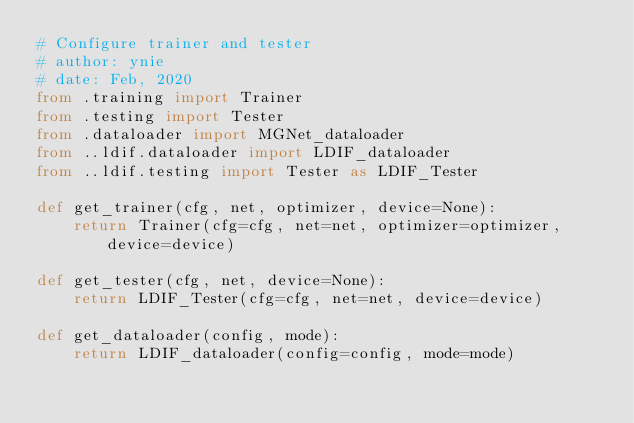Convert code to text. <code><loc_0><loc_0><loc_500><loc_500><_Python_># Configure trainer and tester
# author: ynie
# date: Feb, 2020
from .training import Trainer
from .testing import Tester
from .dataloader import MGNet_dataloader
from ..ldif.dataloader import LDIF_dataloader
from ..ldif.testing import Tester as LDIF_Tester

def get_trainer(cfg, net, optimizer, device=None):
    return Trainer(cfg=cfg, net=net, optimizer=optimizer, device=device)

def get_tester(cfg, net, device=None):
    return LDIF_Tester(cfg=cfg, net=net, device=device)

def get_dataloader(config, mode):
    return LDIF_dataloader(config=config, mode=mode)</code> 